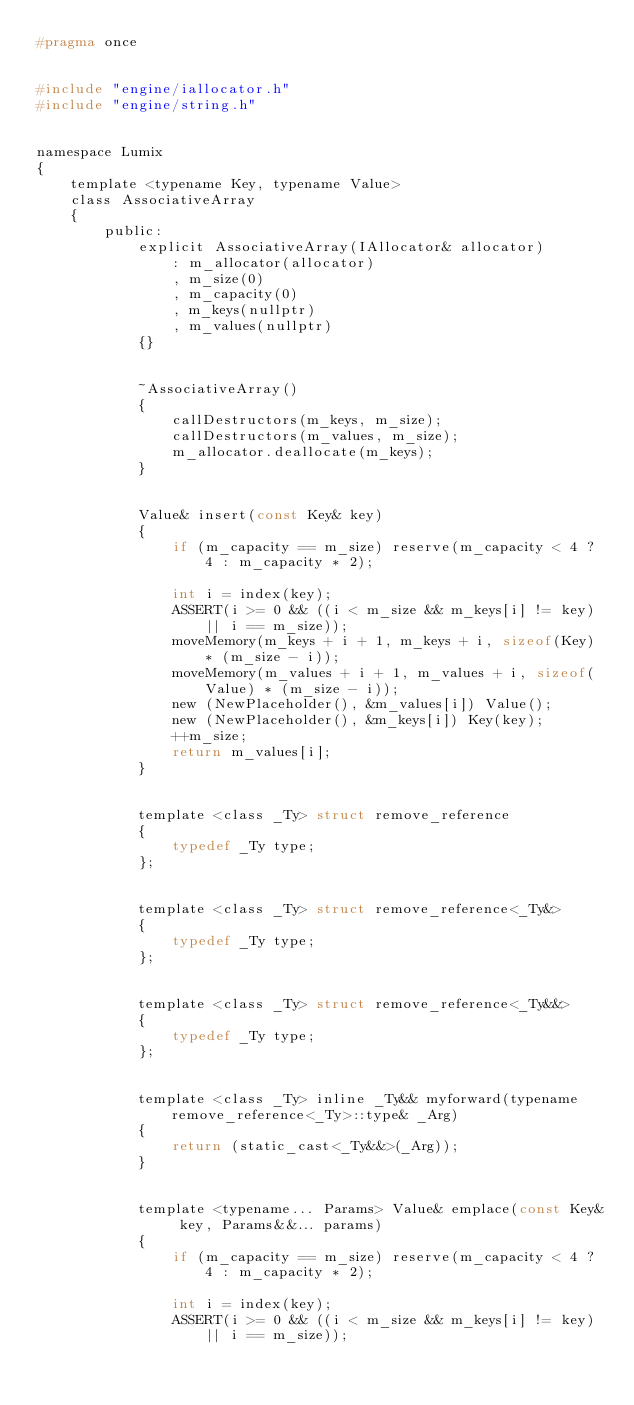Convert code to text. <code><loc_0><loc_0><loc_500><loc_500><_C_>#pragma once


#include "engine/iallocator.h"
#include "engine/string.h"


namespace Lumix
{
	template <typename Key, typename Value>
	class AssociativeArray
	{
		public:
			explicit AssociativeArray(IAllocator& allocator)
				: m_allocator(allocator)
				, m_size(0)
				, m_capacity(0)
				, m_keys(nullptr)
				, m_values(nullptr)
			{}


			~AssociativeArray()
			{
				callDestructors(m_keys, m_size);
				callDestructors(m_values, m_size);
				m_allocator.deallocate(m_keys);
			}


			Value& insert(const Key& key)
			{
				if (m_capacity == m_size) reserve(m_capacity < 4 ? 4 : m_capacity * 2);

				int i = index(key);
				ASSERT(i >= 0 && ((i < m_size && m_keys[i] != key) || i == m_size));
				moveMemory(m_keys + i + 1, m_keys + i, sizeof(Key) * (m_size - i));
				moveMemory(m_values + i + 1, m_values + i, sizeof(Value) * (m_size - i));
				new (NewPlaceholder(), &m_values[i]) Value();
				new (NewPlaceholder(), &m_keys[i]) Key(key);
				++m_size;
				return m_values[i];
			}


			template <class _Ty> struct remove_reference
			{
				typedef _Ty type;
			};


			template <class _Ty> struct remove_reference<_Ty&>
			{
				typedef _Ty type;
			};


			template <class _Ty> struct remove_reference<_Ty&&>
			{
				typedef _Ty type;
			};


			template <class _Ty> inline _Ty&& myforward(typename remove_reference<_Ty>::type& _Arg)
			{
				return (static_cast<_Ty&&>(_Arg));
			}


			template <typename... Params> Value& emplace(const Key& key, Params&&... params)
			{
				if (m_capacity == m_size) reserve(m_capacity < 4 ? 4 : m_capacity * 2);

				int i = index(key);
				ASSERT(i >= 0 && ((i < m_size && m_keys[i] != key) || i == m_size));
</code> 